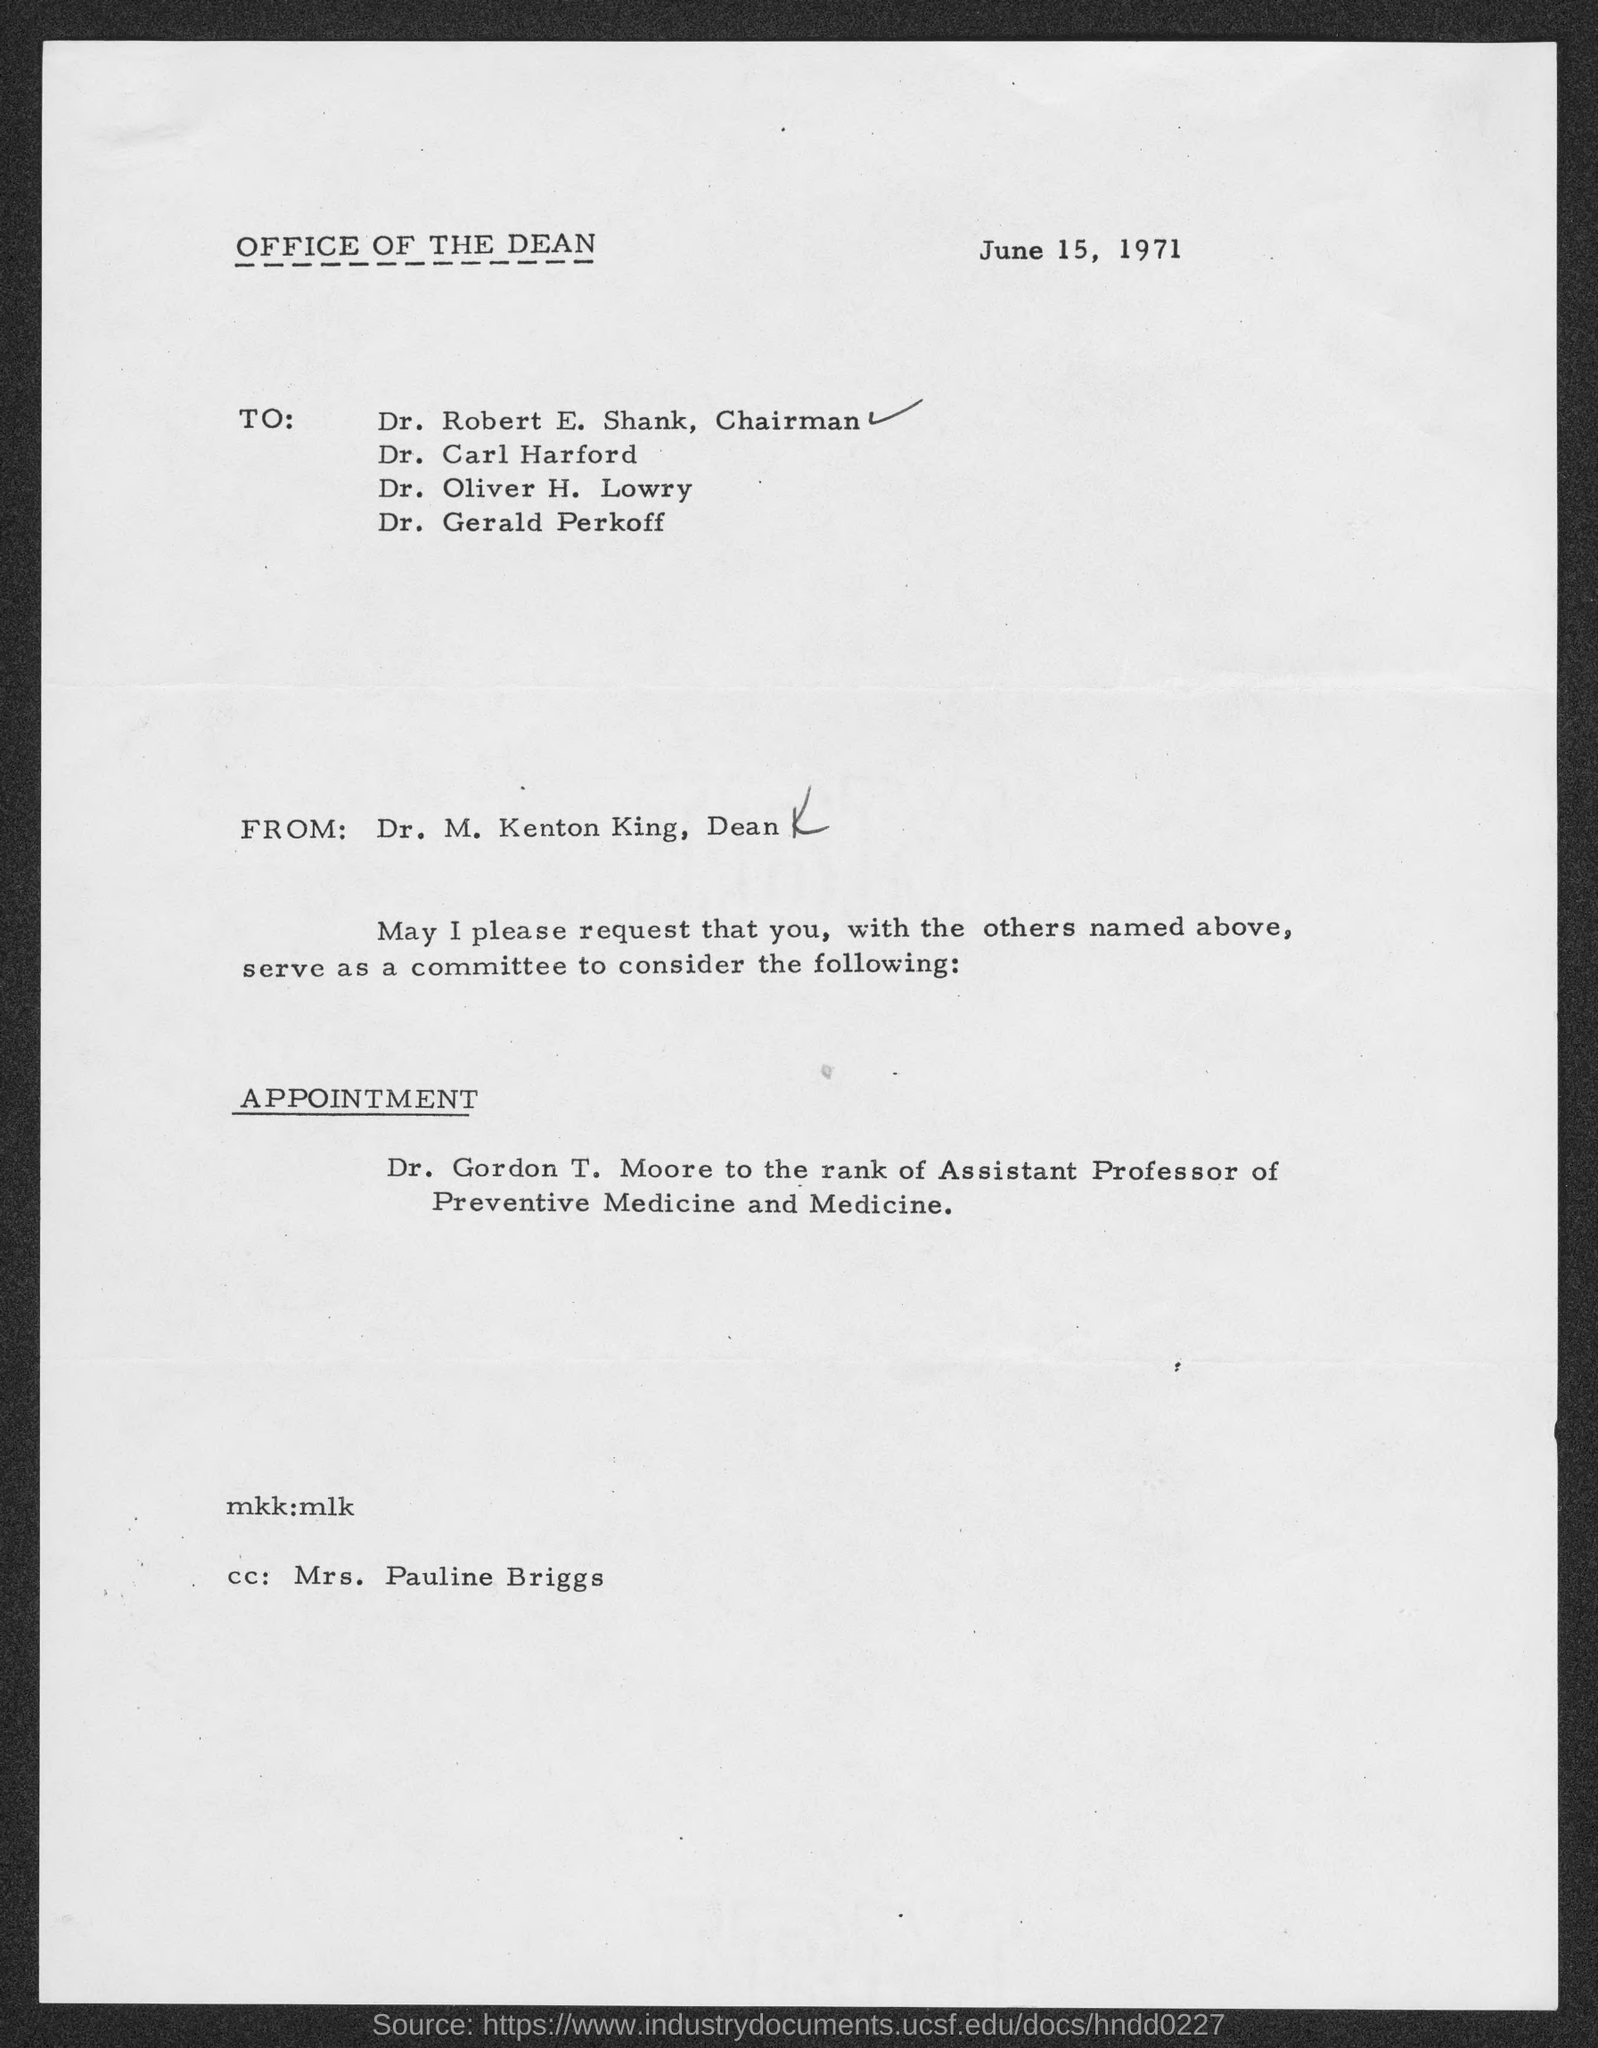When is the document dated?
Provide a short and direct response. June 15, 1971. From whom is the letter?
Give a very brief answer. Dr. m. kenton king, dean. To which rank is Dr. Gordon T. Moore considered?
Your response must be concise. Assistant professor. 